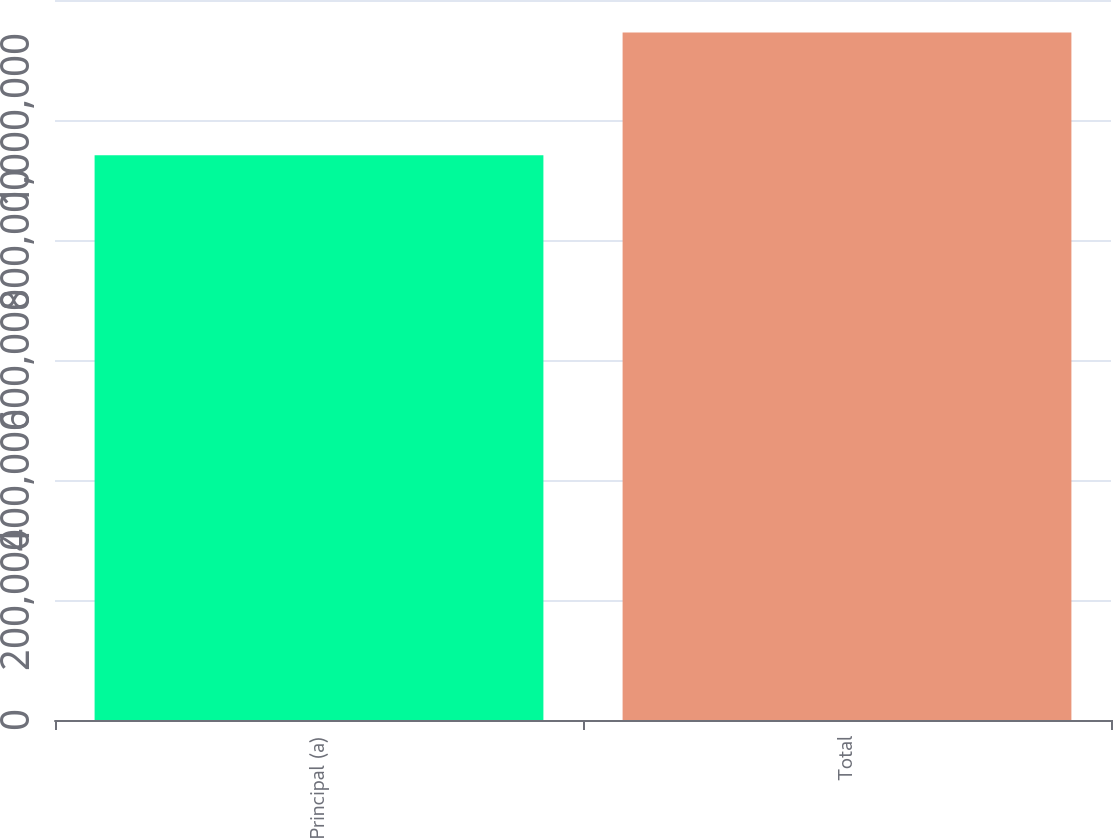Convert chart to OTSL. <chart><loc_0><loc_0><loc_500><loc_500><bar_chart><fcel>Principal (a)<fcel>Total<nl><fcel>941157<fcel>1.14591e+06<nl></chart> 